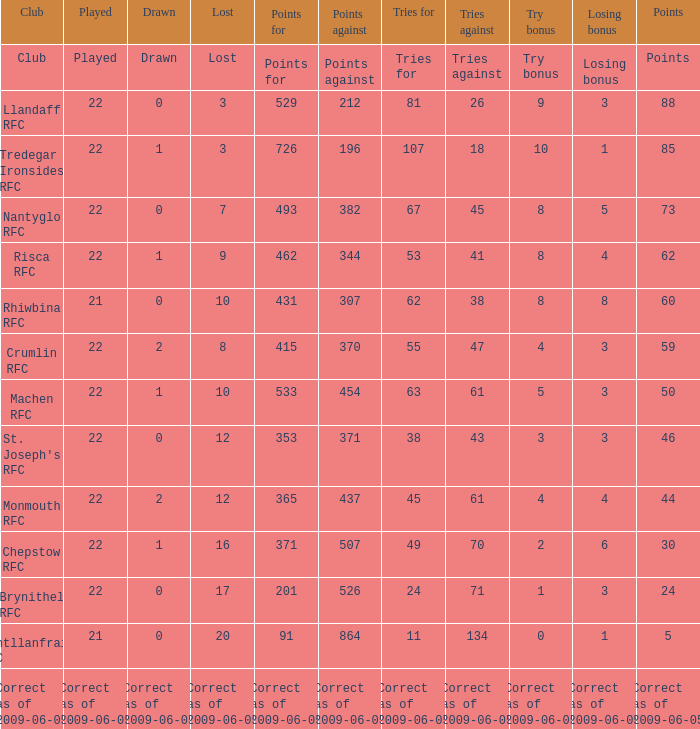If played is 22 and the tries against are 43, what are the points? 353.0. 